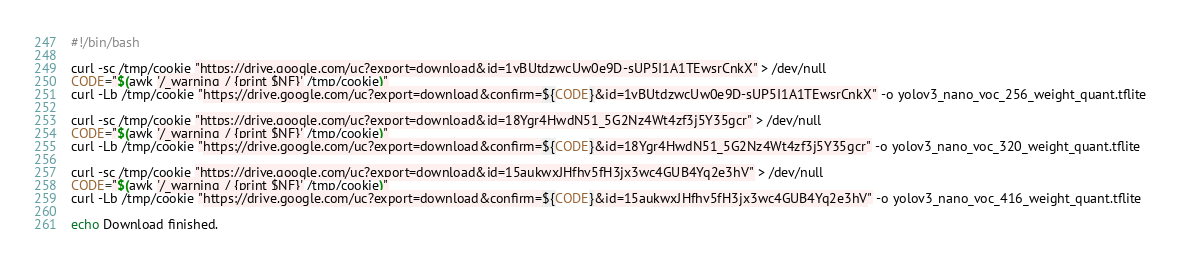<code> <loc_0><loc_0><loc_500><loc_500><_Bash_>#!/bin/bash

curl -sc /tmp/cookie "https://drive.google.com/uc?export=download&id=1vBUtdzwcUw0e9D-sUP5I1A1TEwsrCnkX" > /dev/null
CODE="$(awk '/_warning_/ {print $NF}' /tmp/cookie)"
curl -Lb /tmp/cookie "https://drive.google.com/uc?export=download&confirm=${CODE}&id=1vBUtdzwcUw0e9D-sUP5I1A1TEwsrCnkX" -o yolov3_nano_voc_256_weight_quant.tflite

curl -sc /tmp/cookie "https://drive.google.com/uc?export=download&id=18Ygr4HwdN51_5G2Nz4Wt4zf3j5Y35gcr" > /dev/null
CODE="$(awk '/_warning_/ {print $NF}' /tmp/cookie)"
curl -Lb /tmp/cookie "https://drive.google.com/uc?export=download&confirm=${CODE}&id=18Ygr4HwdN51_5G2Nz4Wt4zf3j5Y35gcr" -o yolov3_nano_voc_320_weight_quant.tflite

curl -sc /tmp/cookie "https://drive.google.com/uc?export=download&id=15aukwxJHfhv5fH3jx3wc4GUB4Yq2e3hV" > /dev/null
CODE="$(awk '/_warning_/ {print $NF}' /tmp/cookie)"
curl -Lb /tmp/cookie "https://drive.google.com/uc?export=download&confirm=${CODE}&id=15aukwxJHfhv5fH3jx3wc4GUB4Yq2e3hV" -o yolov3_nano_voc_416_weight_quant.tflite

echo Download finished.</code> 